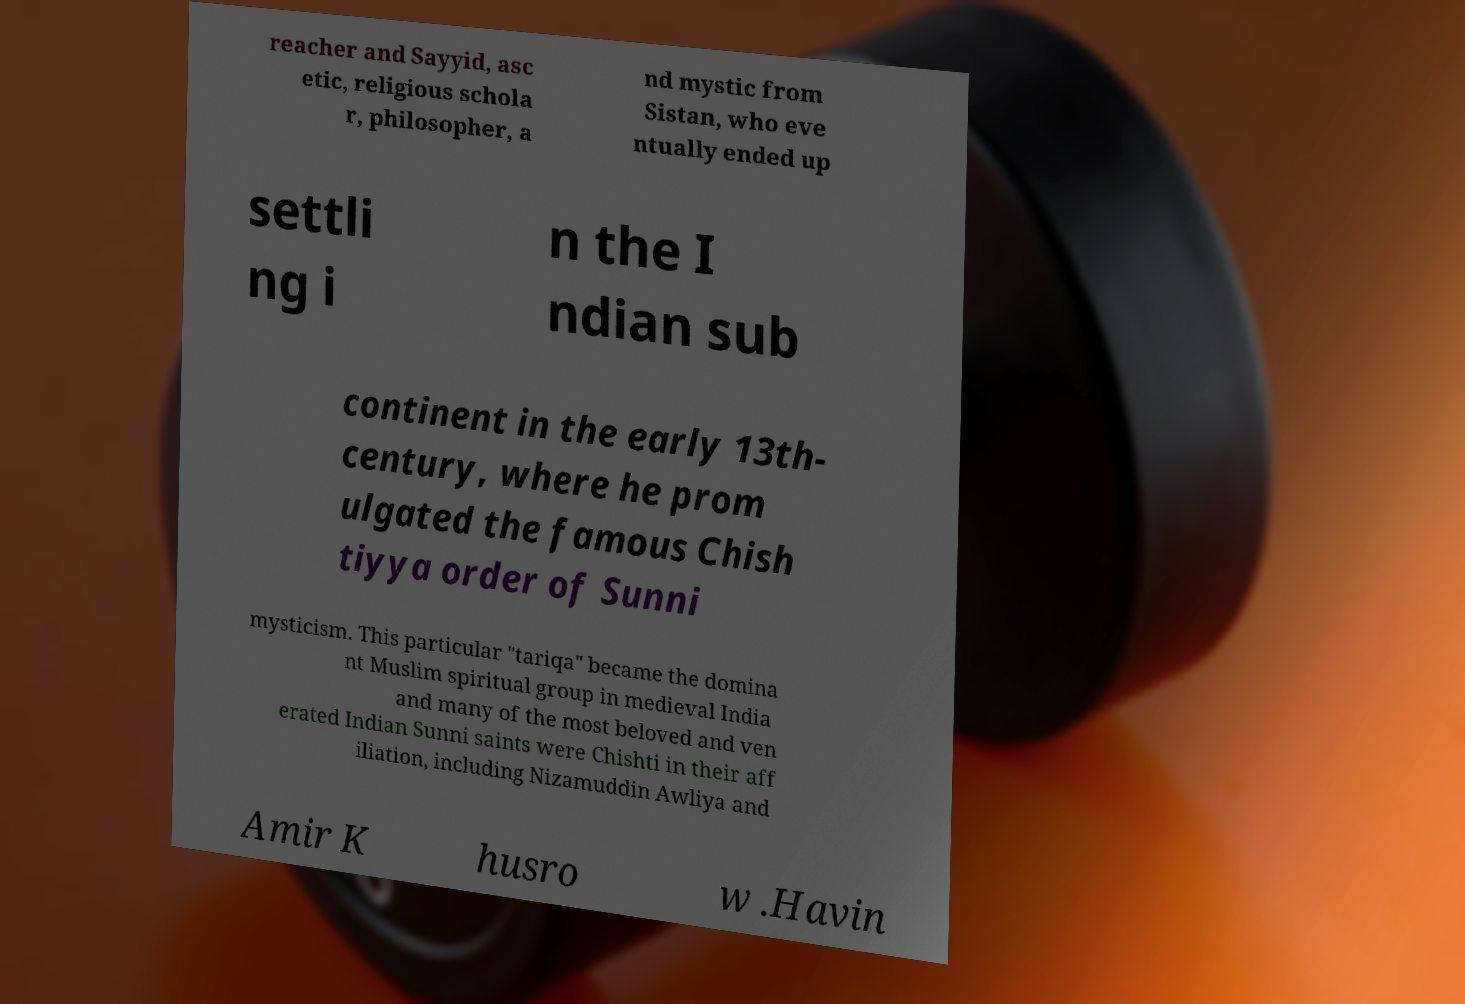Please read and relay the text visible in this image. What does it say? reacher and Sayyid, asc etic, religious schola r, philosopher, a nd mystic from Sistan, who eve ntually ended up settli ng i n the I ndian sub continent in the early 13th- century, where he prom ulgated the famous Chish tiyya order of Sunni mysticism. This particular "tariqa" became the domina nt Muslim spiritual group in medieval India and many of the most beloved and ven erated Indian Sunni saints were Chishti in their aff iliation, including Nizamuddin Awliya and Amir K husro w .Havin 